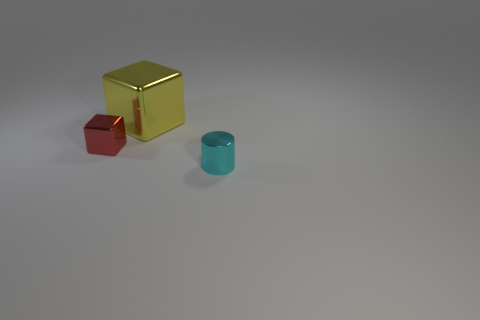Are there the same number of tiny things that are right of the small red block and large metal things?
Offer a terse response. Yes. Are there any small metal blocks that are to the right of the tiny metal object that is behind the small metallic thing that is right of the tiny block?
Provide a succinct answer. No. What is the material of the red thing?
Ensure brevity in your answer.  Metal. What number of other objects are the same shape as the cyan metallic thing?
Your answer should be very brief. 0. Does the yellow object have the same shape as the cyan object?
Ensure brevity in your answer.  No. How many objects are either objects in front of the large metallic cube or objects behind the tiny cyan metal cylinder?
Provide a succinct answer. 3. How many things are either metallic things or purple cylinders?
Your answer should be compact. 3. There is a thing that is left of the big thing; how many cyan cylinders are in front of it?
Provide a succinct answer. 1. How many other objects are there of the same size as the metal cylinder?
Keep it short and to the point. 1. Is the shape of the small object that is on the left side of the yellow thing the same as  the cyan thing?
Provide a succinct answer. No. 